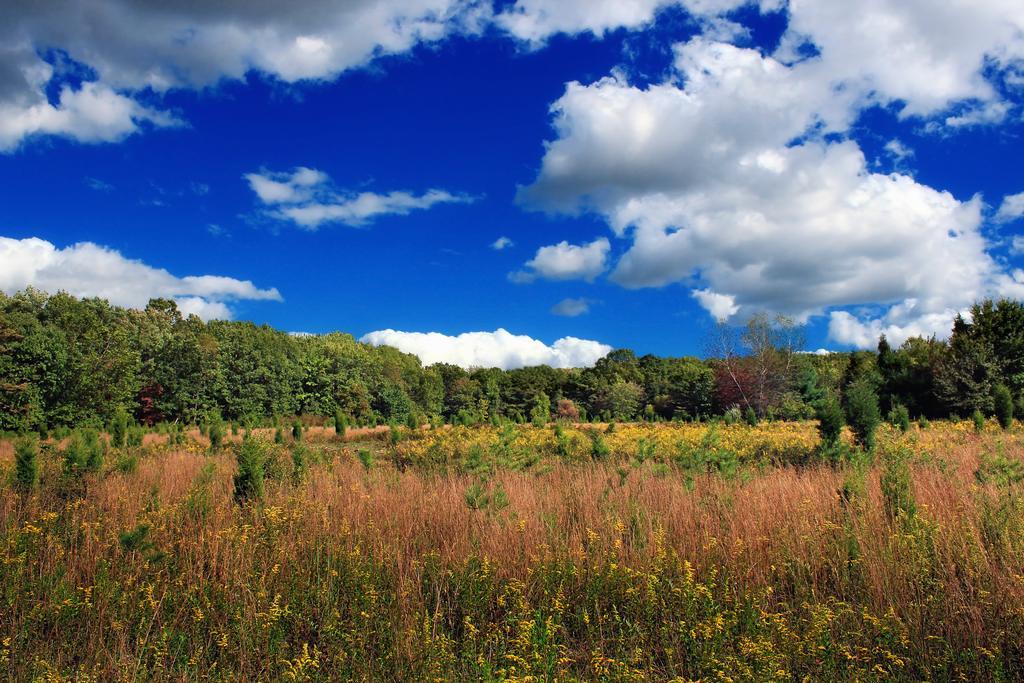Can you describe this image briefly? In this image, we can see some trees and plants. There are clouds in the sky. 